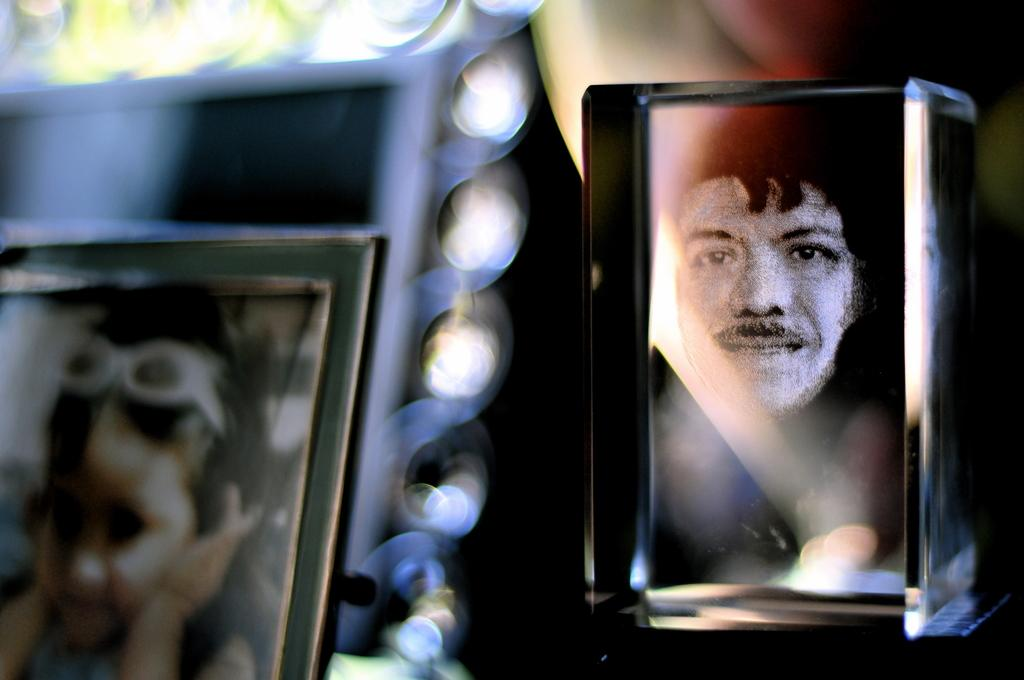What objects are visible in the image that are related to displaying photographs? There are photo frames visible in the image. What type of holiday is being celebrated in the image? There is no indication of a holiday being celebrated in the image, as the only visible object is the photo frames. What type of nerve is being stimulated by the photo frames in the image? The photo frames in the image are not related to stimulating any nerves; they are used for displaying photographs. 